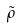Convert formula to latex. <formula><loc_0><loc_0><loc_500><loc_500>\tilde { \rho }</formula> 